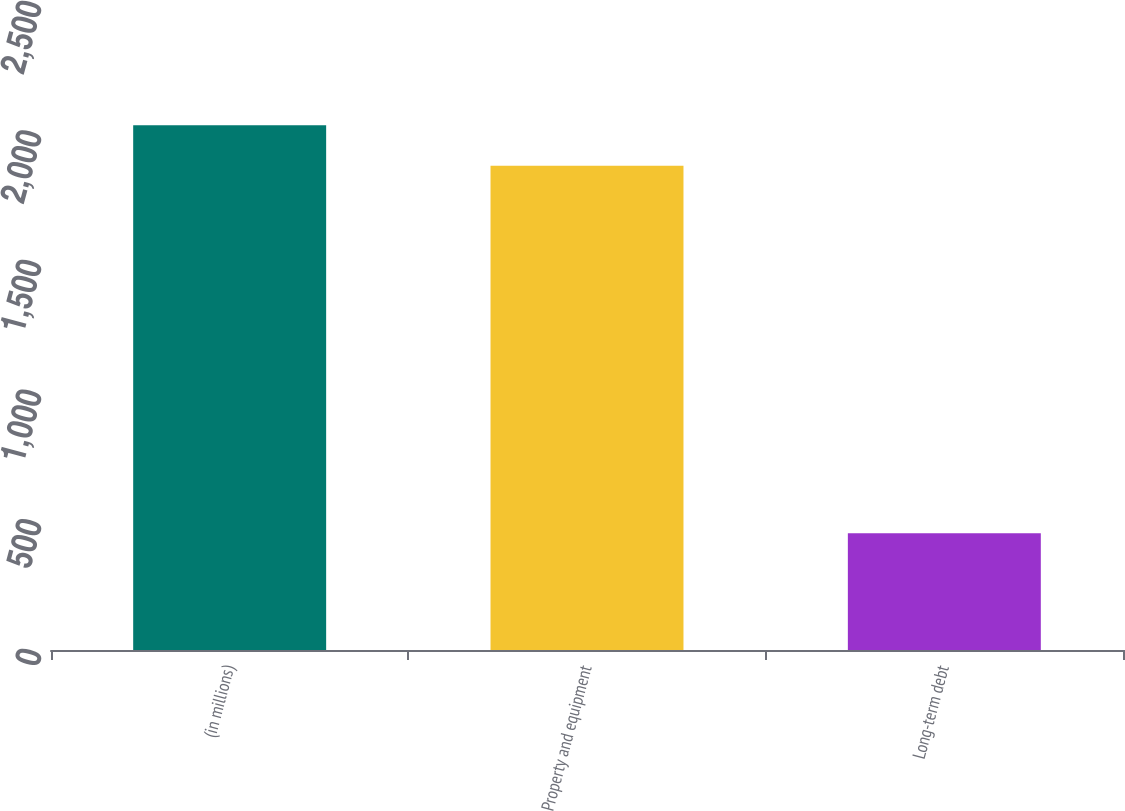Convert chart. <chart><loc_0><loc_0><loc_500><loc_500><bar_chart><fcel>(in millions)<fcel>Property and equipment<fcel>Long-term debt<nl><fcel>2024.5<fcel>1868<fcel>450<nl></chart> 